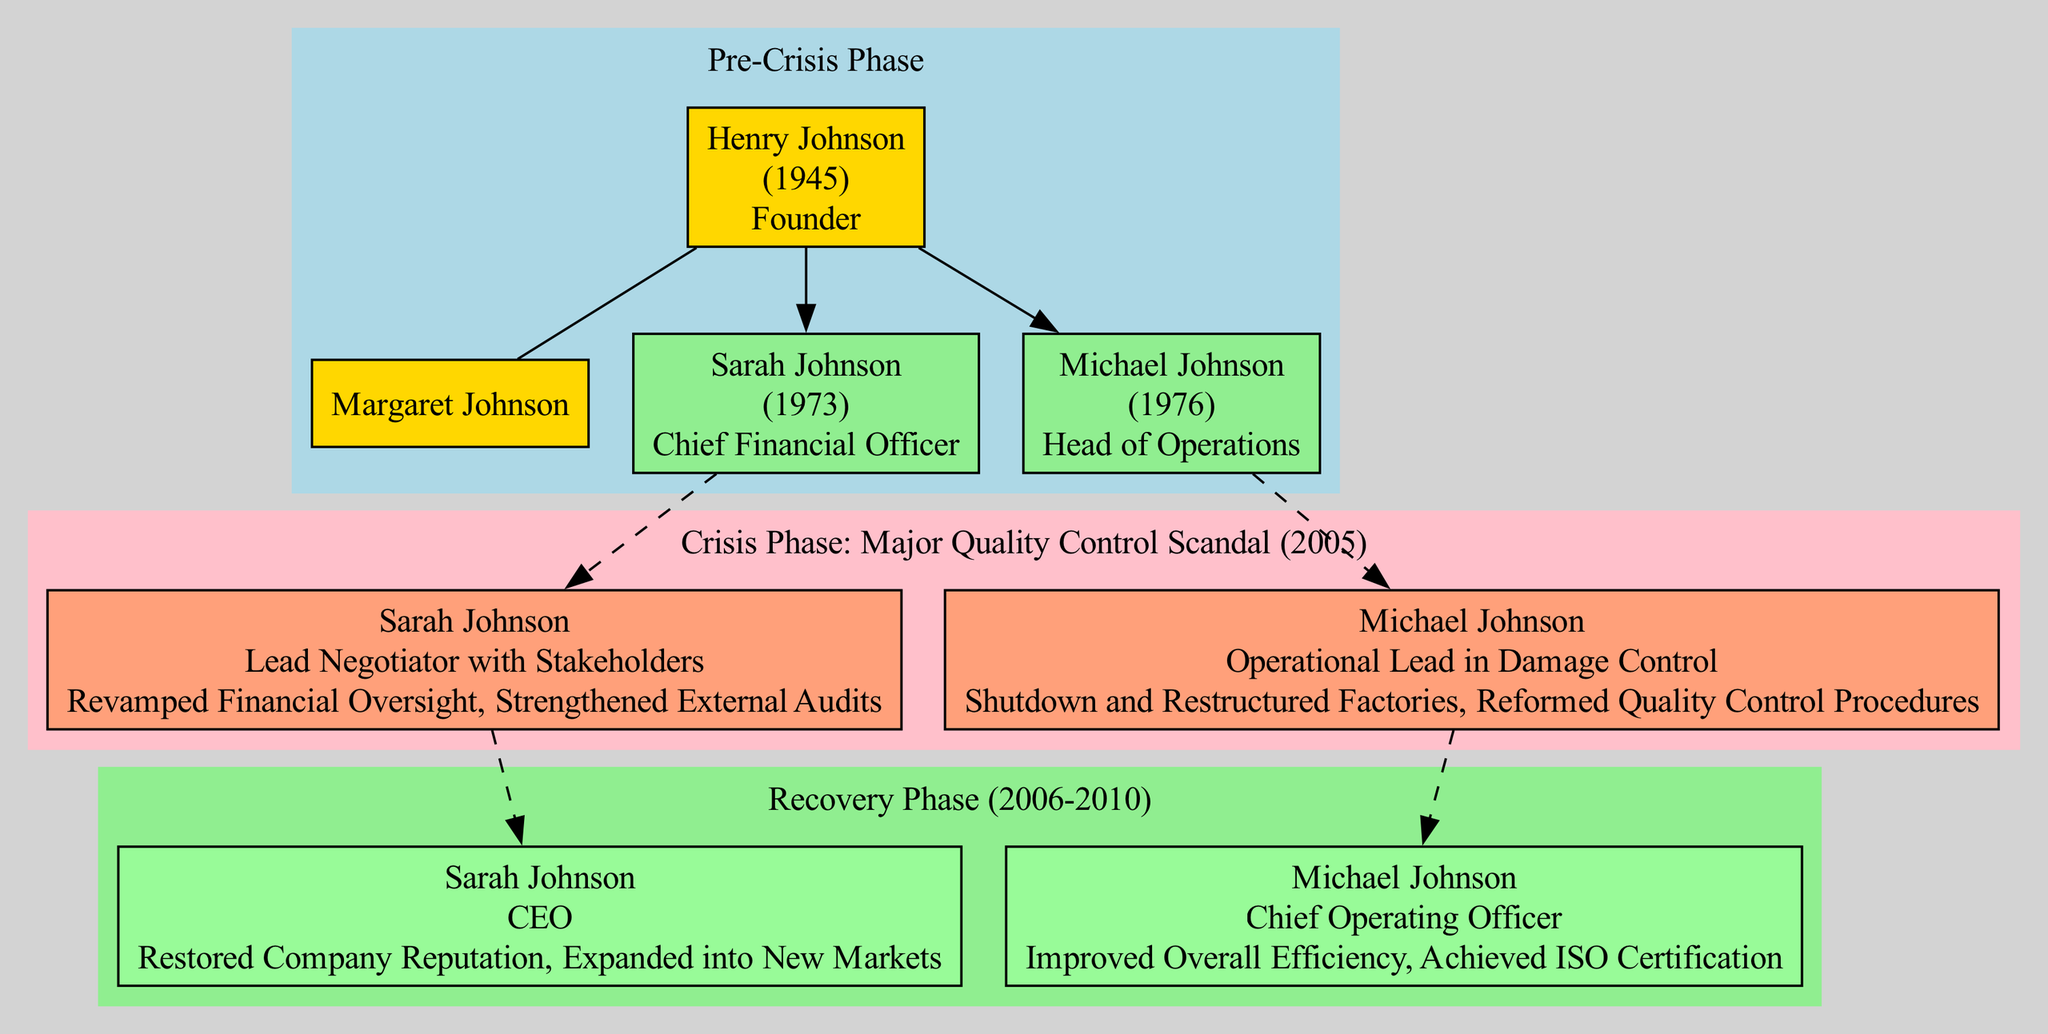What is the name of the founder? In the Pre-Crisis Phase, the section labeled "founder" provides the information on who founded the business. The name stated there is Henry Johnson.
Answer: Henry Johnson How many children did the founder have? Under the Pre-Crisis Phase, there are two nodes representing children (child_1 and child_2) connected to the founder. Thus, the total number of children is two.
Answer: 2 What event triggered the Crisis Phase? The Crisis Phase provides an event description, which states "Major Quality Control Scandal." This event is connected to the year 2005.
Answer: Major Quality Control Scandal Who was the Chief Financial Officer during the Crisis Phase? In the Crisis Phase section, Sarah Johnson is listed with a role during the crisis as "Lead Negotiator with Stakeholders," and her original role in business was Chief Financial Officer as seen in the Pre-Crisis Phase.
Answer: Sarah Johnson What strategies were employed during the Recovery Phase? The Recovery Phase nodes list “Increased Transparency” and “Corporate Social Responsibility Initiatives” as strategies that were implemented during this time.
Answer: Increased Transparency, Corporate Social Responsibility Initiatives What significant role did Sarah Johnson take on after the Crisis Phase? In the Recovery Phase section, it specifies that Sarah Johnson transitioned to the role of CEO, which represents a significant leadership position following the crisis.
Answer: CEO How did Michael Johnson contribute to damage control during the Crisis Phase? During the Crisis Phase, it's noted that Michael Johnson's role was "Operational Lead in Damage Control," and he took specific actions such as shutting down and restructuring factories and reforming quality control procedures.
Answer: Shutdown and Restructured Factories, Reformed Quality Control Procedures What achievement did Michael Johnson secure in the Recovery Phase? In the Recovery Phase, one of the key achievements listed for Michael Johnson is that he "Achieved ISO Certification," marking a significant milestone for the business.
Answer: Achieved ISO Certification What is the relationship between Henry Johnson and Margaret Johnson? The diagram illustrates that Margaret Johnson is connected to Henry Johnson as his spouse in the Pre-Crisis Phase, indicating their marriage.
Answer: Spouses 